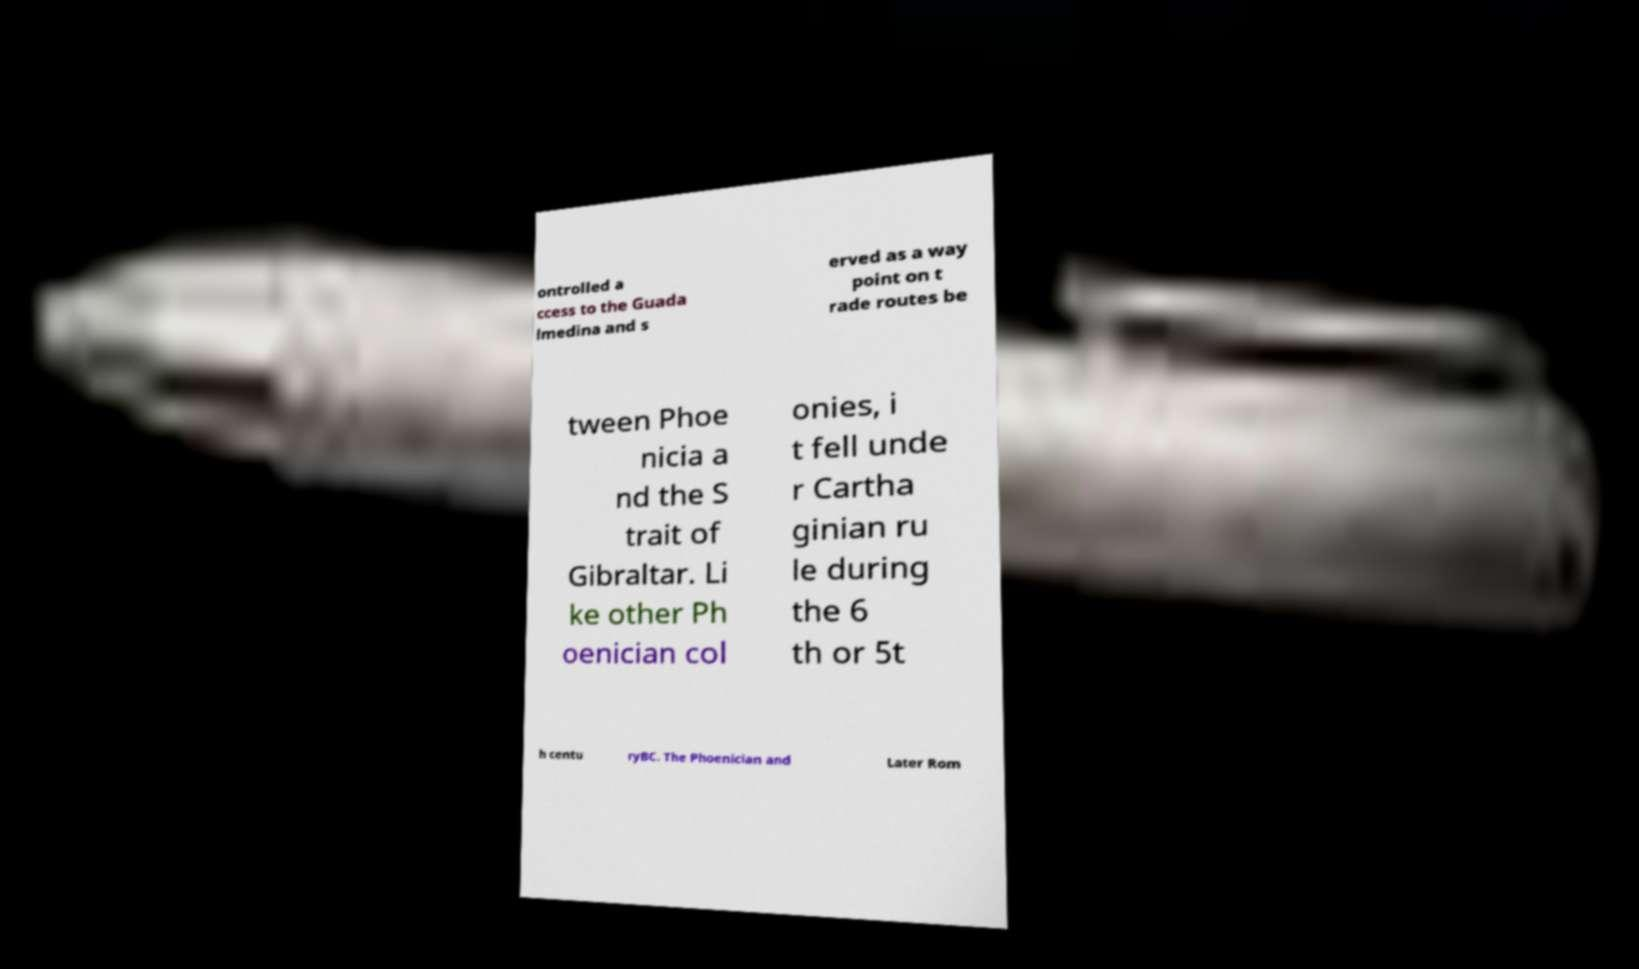Could you extract and type out the text from this image? ontrolled a ccess to the Guada lmedina and s erved as a way point on t rade routes be tween Phoe nicia a nd the S trait of Gibraltar. Li ke other Ph oenician col onies, i t fell unde r Cartha ginian ru le during the 6 th or 5t h centu ryBC. The Phoenician and Later Rom 